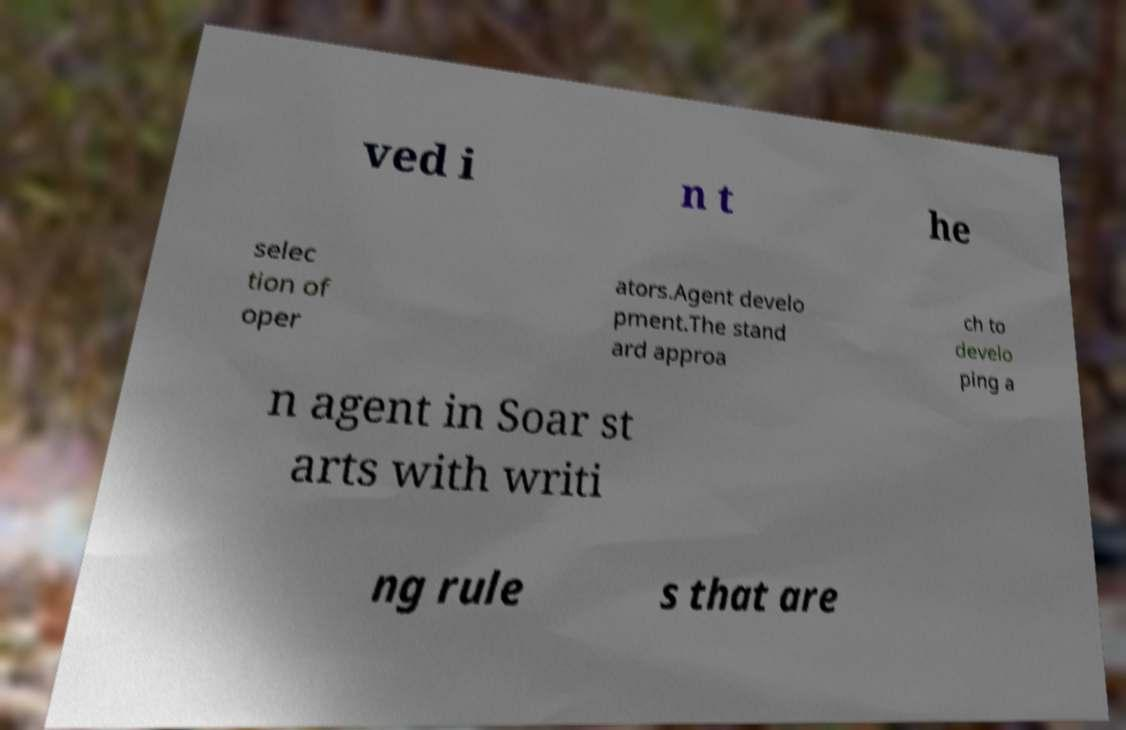Please identify and transcribe the text found in this image. ved i n t he selec tion of oper ators.Agent develo pment.The stand ard approa ch to develo ping a n agent in Soar st arts with writi ng rule s that are 